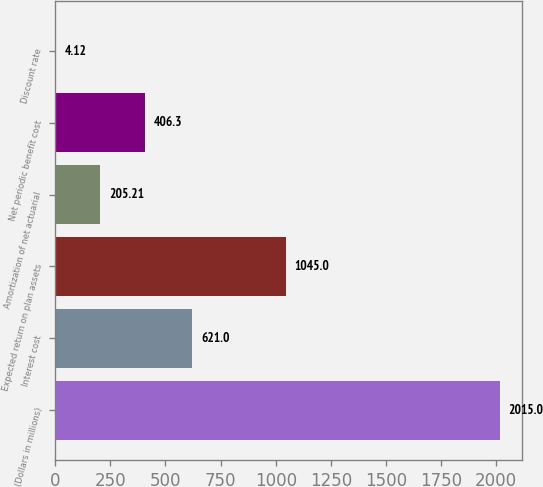Convert chart to OTSL. <chart><loc_0><loc_0><loc_500><loc_500><bar_chart><fcel>(Dollars in millions)<fcel>Interest cost<fcel>Expected return on plan assets<fcel>Amortization of net actuarial<fcel>Net periodic benefit cost<fcel>Discount rate<nl><fcel>2015<fcel>621<fcel>1045<fcel>205.21<fcel>406.3<fcel>4.12<nl></chart> 